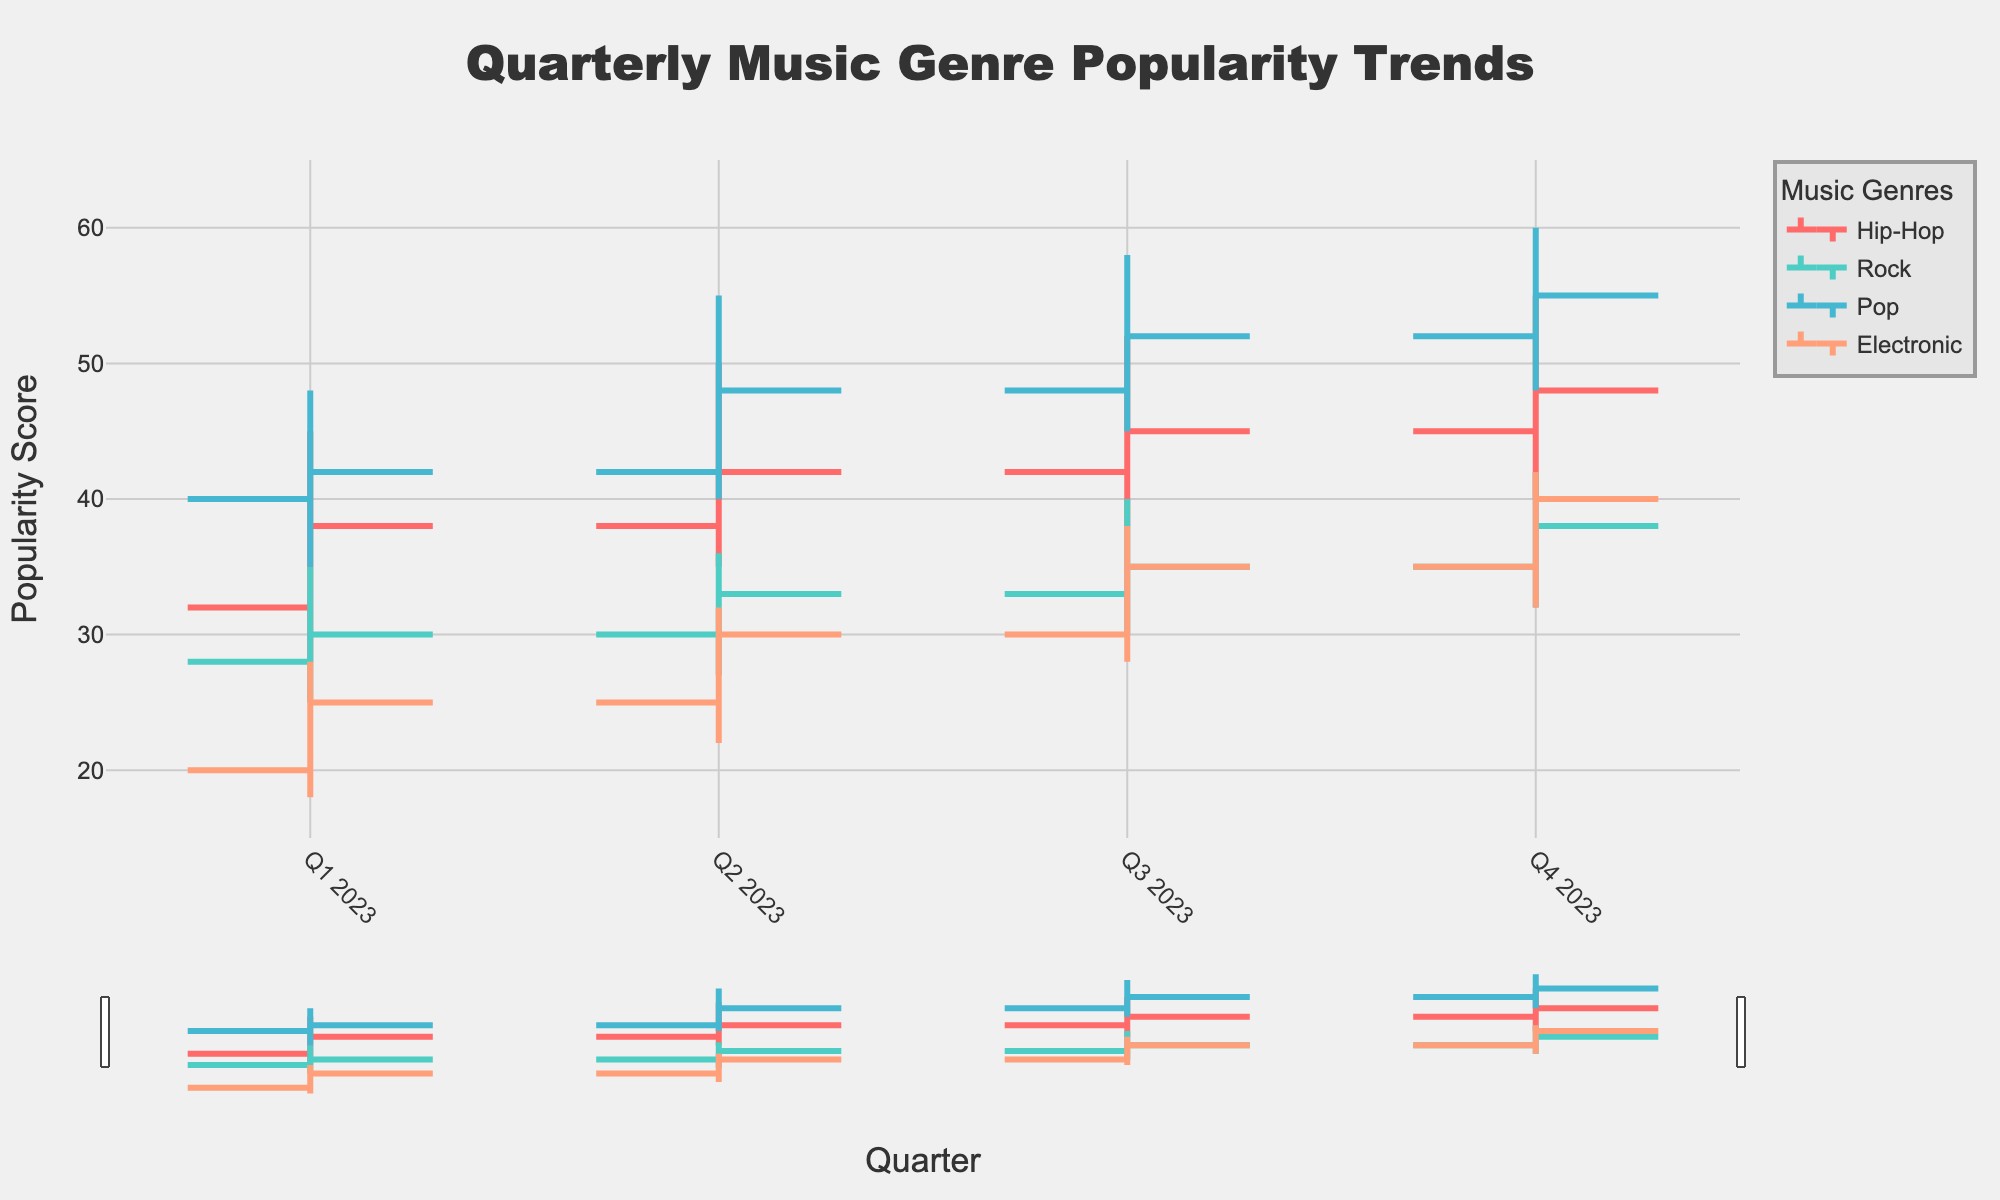What is the title of the chart? The title of the chart is located at the top and is meant to give a brief description of what the chart represents.
Answer: Quarterly Music Genre Popularity Trends What is the lowest popularity score recorded in Q1 2023? By examining Q1 2023, we see the lowest value for each genre. Among Hip-Hop (28), Rock (25), Pop (35), and Electronic (18), Electronic has the lowest score.
Answer: 18 Which genre had the highest ending popularity score in Q4 2023? We need to find the 'Close' value for each genre in Q4 2023. Hip-Hop ended at 48, Rock at 38, Pop at 55, and Electronic at 40. Pop has the highest ending score.
Answer: Pop What was the overall trend for Hip-Hop from Q1 2023 to Q4 2023? Check the 'Close' values for Hip-Hop: Q1 2023 (38), Q2 2023 (42), Q3 2023 (45), Q4 2023 (48). The trend shows a consistent increase in popularity.
Answer: Increasing Which genre experienced the largest increase in its highest popularity score from Q1 to Q4 2023? To determine the largest increase, we calculate the difference between the 'High' values of Q4 and Q1 for each genre: Hip-Hop (55 - 45 = 10), Rock (42 - 35 = 7), Pop (60 - 48 = 12), Electronic (42 - 28 = 14). Electronic has the largest increase.
Answer: Electronic How did the popularity of Rock change from Q3 2023 to Q4 2023? Look at the 'Close' values for Rock in Q3 and Q4. Q3 2023 had a value of 35, and Q4 2023 had a value of 38. This indicates an increase.
Answer: Increased What is the range of the popularity scores for Electronic in Q4 2023? The range is calculated by subtracting the 'Low' value from the 'High' value for Electronic in Q4 2023. Highest value is 42, and lowest is 32, thus the range is 42 - 32.
Answer: 10 Comparing Q2 2023 and Q3 2023, which genre saw the highest increase in its opening popularity score? Calculate the difference in the 'Open' value between Q2 and Q3 for each genre: Hip-Hop (42 - 38 = 4), Rock (33 - 30 = 3), Pop (48 - 42 = 6), Electronic (30 - 25 = 5). The genre with the highest increase is Pop.
Answer: Pop What is the average popularity of Pop across all quarters? The average is calculated as the sum of 'Close' values of each quarter divided by the number of quarters. For Pop: (42 + 48 + 52 + 55)/4 = 197/4.
Answer: 49.25 Between Hip-Hop and Rock, which genre had the most stable popularity in Q2 2023? Stability can be judged by the range (High - Low). For Hip-Hop: 50 - 35 = 15, for Rock: 36 - 27 = 9. Rock has a smaller range, hence more stable.
Answer: Rock 